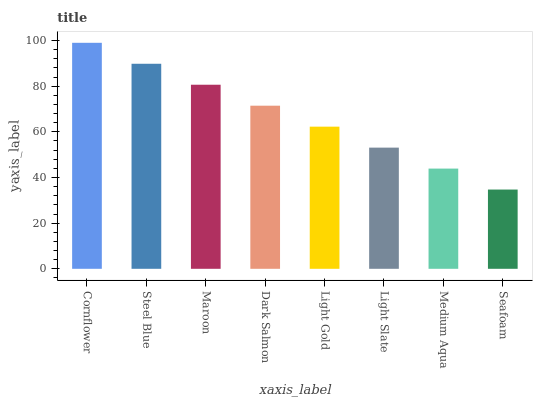Is Seafoam the minimum?
Answer yes or no. Yes. Is Cornflower the maximum?
Answer yes or no. Yes. Is Steel Blue the minimum?
Answer yes or no. No. Is Steel Blue the maximum?
Answer yes or no. No. Is Cornflower greater than Steel Blue?
Answer yes or no. Yes. Is Steel Blue less than Cornflower?
Answer yes or no. Yes. Is Steel Blue greater than Cornflower?
Answer yes or no. No. Is Cornflower less than Steel Blue?
Answer yes or no. No. Is Dark Salmon the high median?
Answer yes or no. Yes. Is Light Gold the low median?
Answer yes or no. Yes. Is Cornflower the high median?
Answer yes or no. No. Is Medium Aqua the low median?
Answer yes or no. No. 